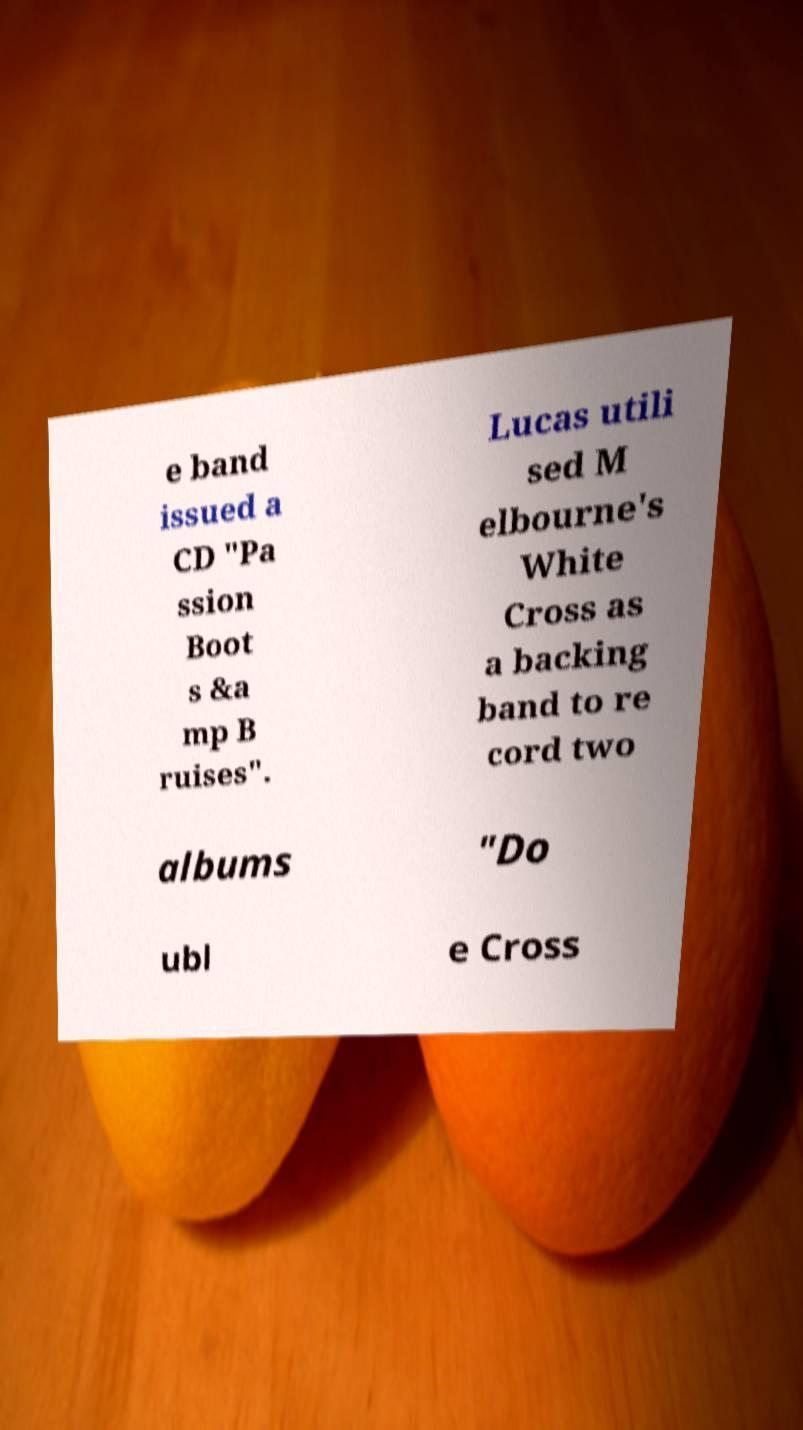Please identify and transcribe the text found in this image. e band issued a CD "Pa ssion Boot s &a mp B ruises". Lucas utili sed M elbourne's White Cross as a backing band to re cord two albums "Do ubl e Cross 